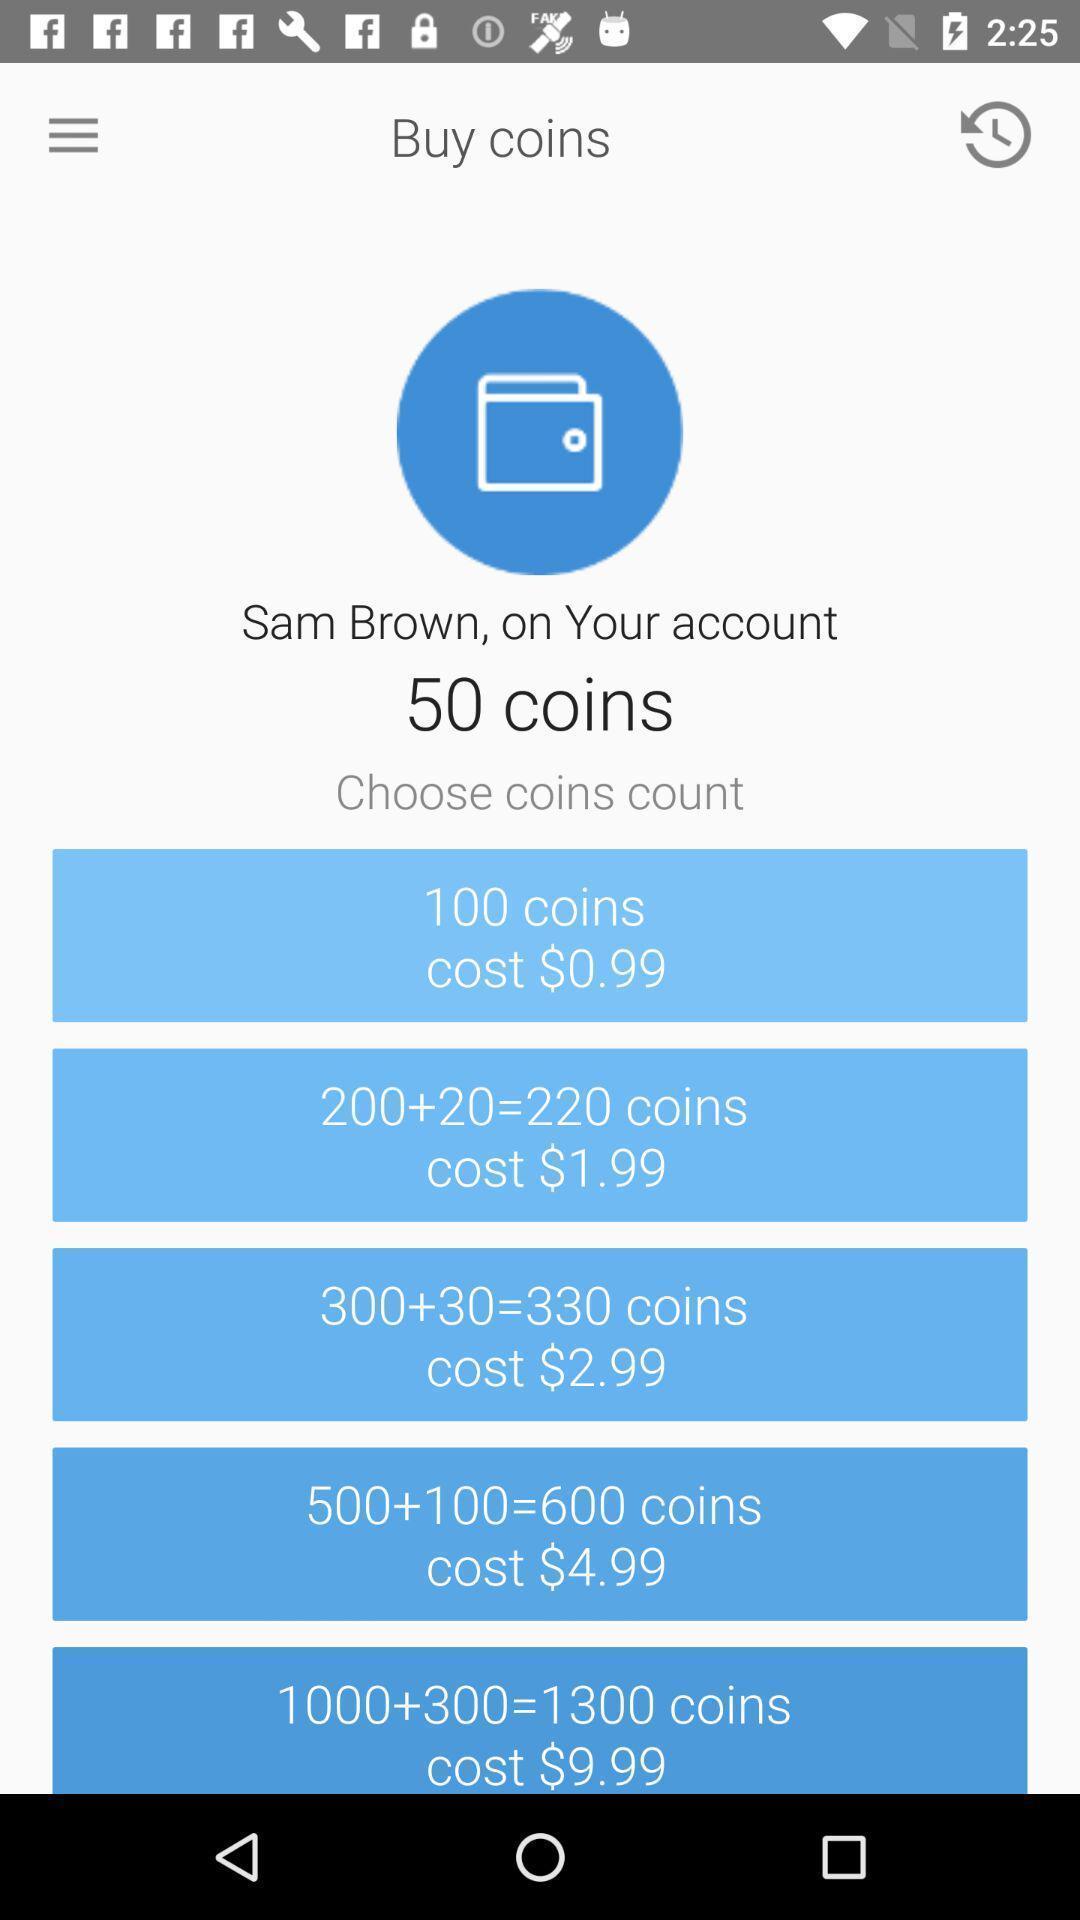Describe the key features of this screenshot. Screen shows coins information. 